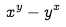Convert formula to latex. <formula><loc_0><loc_0><loc_500><loc_500>x ^ { y } - y ^ { x }</formula> 